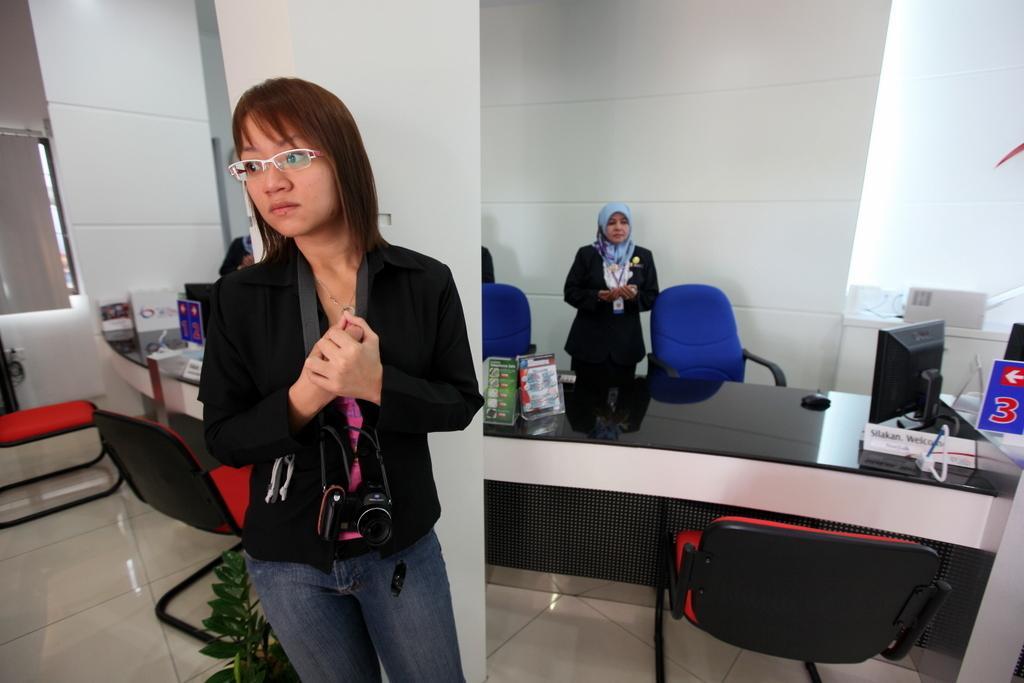Describe this image in one or two sentences. In the picture I can see chairs, people standing on the floor, a monitor and some other objects on the floor. 